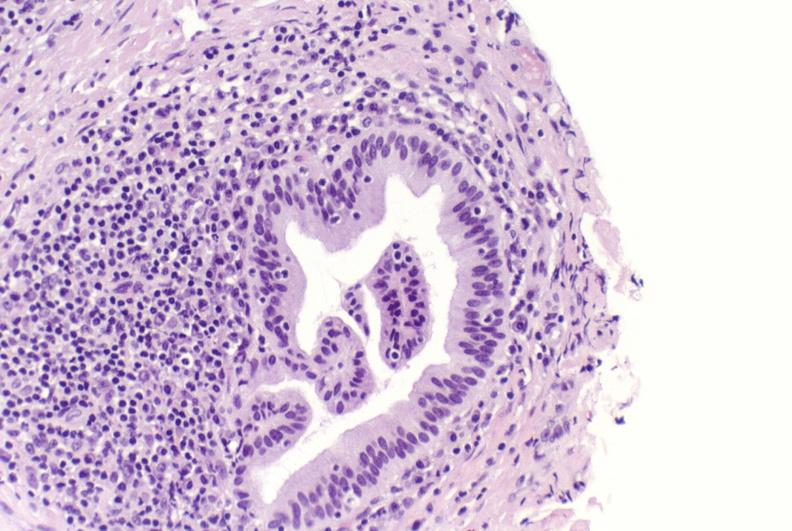s this good yellow color slide present?
Answer the question using a single word or phrase. No 